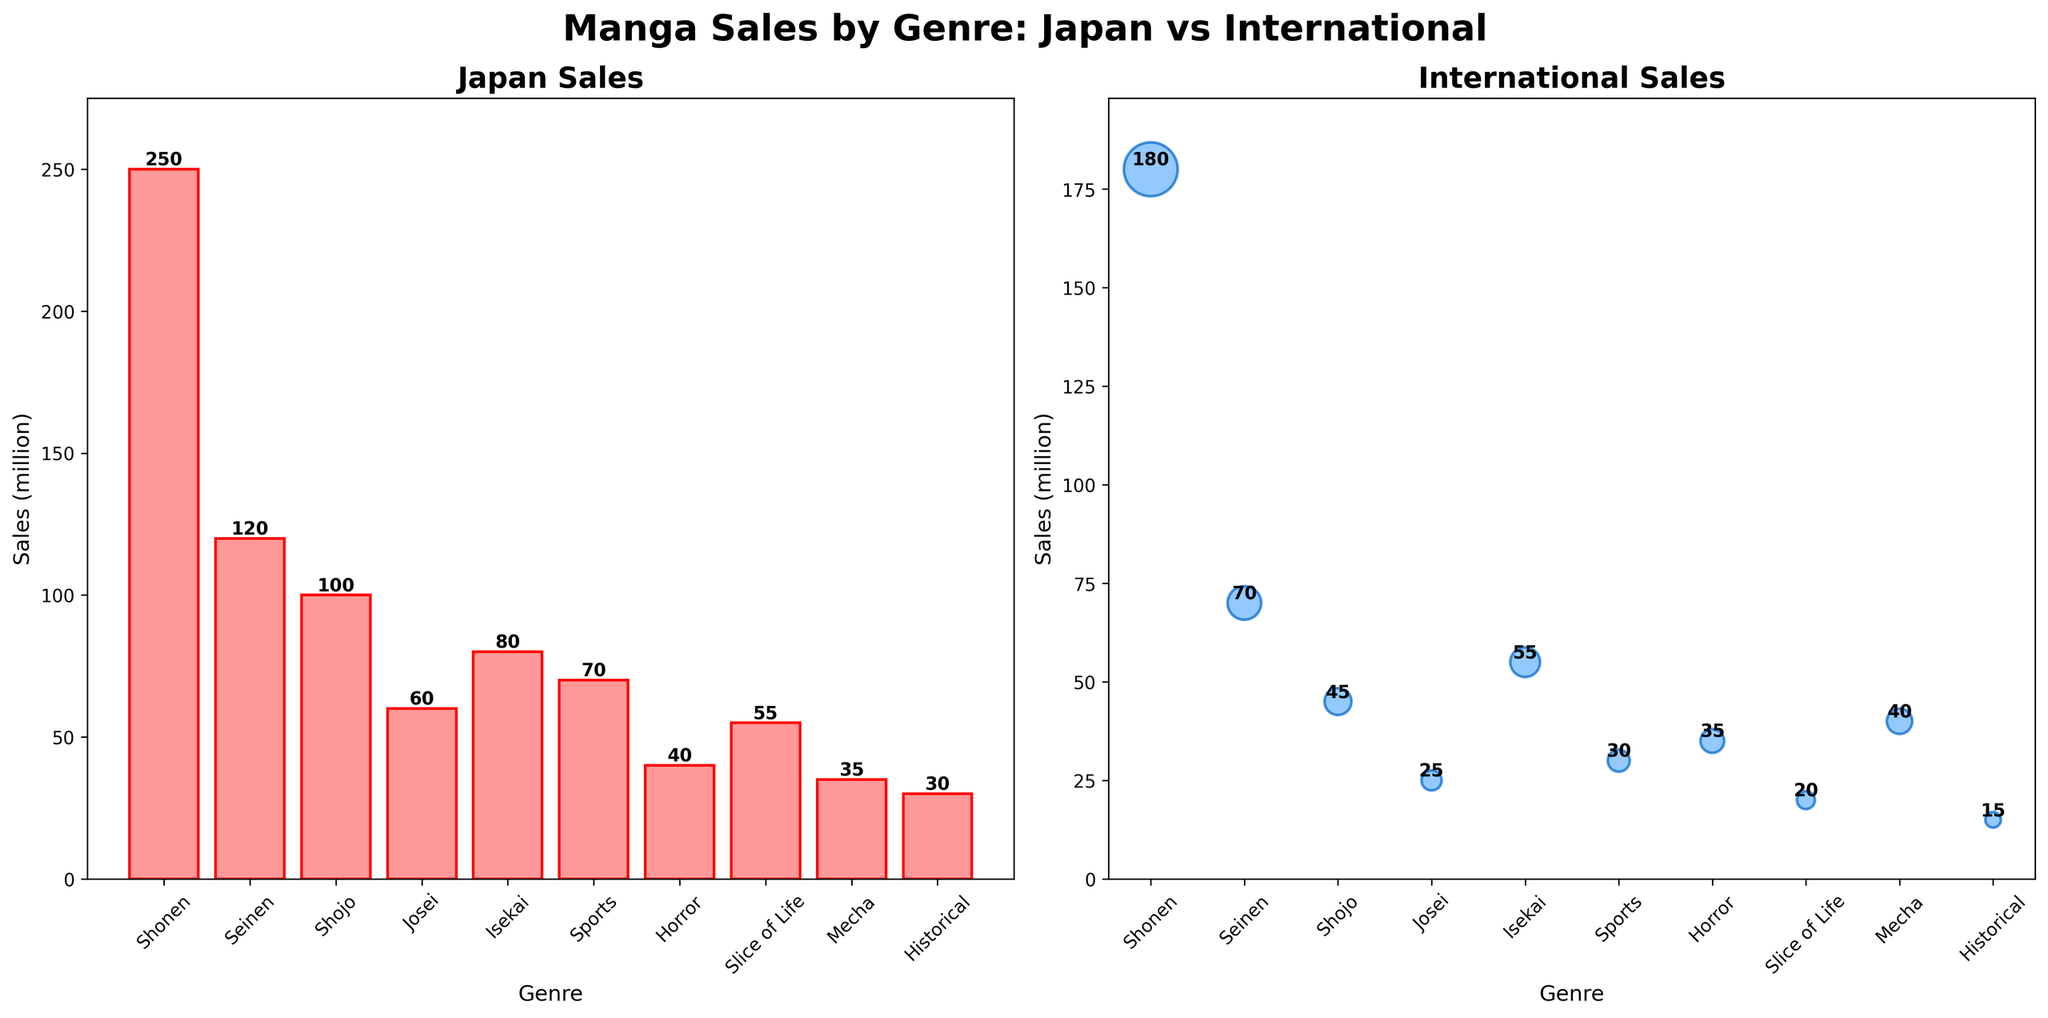What is the title of the figure? The title is displayed prominently at the top of the figure in bold, large font. It reads 'Manga Sales by Genre: Japan vs International'.
Answer: Manga Sales by Genre: Japan vs International Which genre has the highest sales in Japan? The bar plot on the left side shows the sales in Japan, with the largest bar representing the genre 'Shonen' at 250 million.
Answer: Shonen Which genre has the lowest international sales? The scatter plot on the right side represents international sales, and the smallest circle corresponds to 'Historical' at 15 million.
Answer: Historical What is the sum of Japan's sales for 'Shonen' and 'Seinen'? From the bar plot, 'Shonen' has 250 million and 'Seinen' has 120 million in Japan. Adding these gives 250 + 120 = 370 million.
Answer: 370 million Which genre shows higher international sales than Japan sales? The scatter plot on the right and bar plot on the left can be compared. 'Mecha' has 35 million in Japan and 40 million internationally.
Answer: Mecha What colors are used to represent Japan sales and International sales? Japan sales use pink shades with red edges, and International sales use blue shades with darker blue edges.
Answer: Pink with red edges (Japan), Blue with darker blue edges (International) What is the difference between Japan and International sales for 'Sports' genre? From the plots, 'Sports' has 70 million in Japan and 30 million internationally. The difference is 70 - 30 = 40 million.
Answer: 40 million On which subplot are the genres displayed as a scatter plot? The subplot on the right side uses a scatter plot to display genres and their sales internationally.
Answer: Right subplot (International) What is the average sales for 'Shojo' and 'Josei' genres in Japan? 'Shojo' has 100 million and 'Josei' has 60 million in Japan. The average is (100 + 60) / 2 = 80 million.
Answer: 80 million Which genre has the second highest sales in Japan? Looking at the bar plot, 'Seinen' has the second highest sales in Japan with 120 million.
Answer: Seinen 